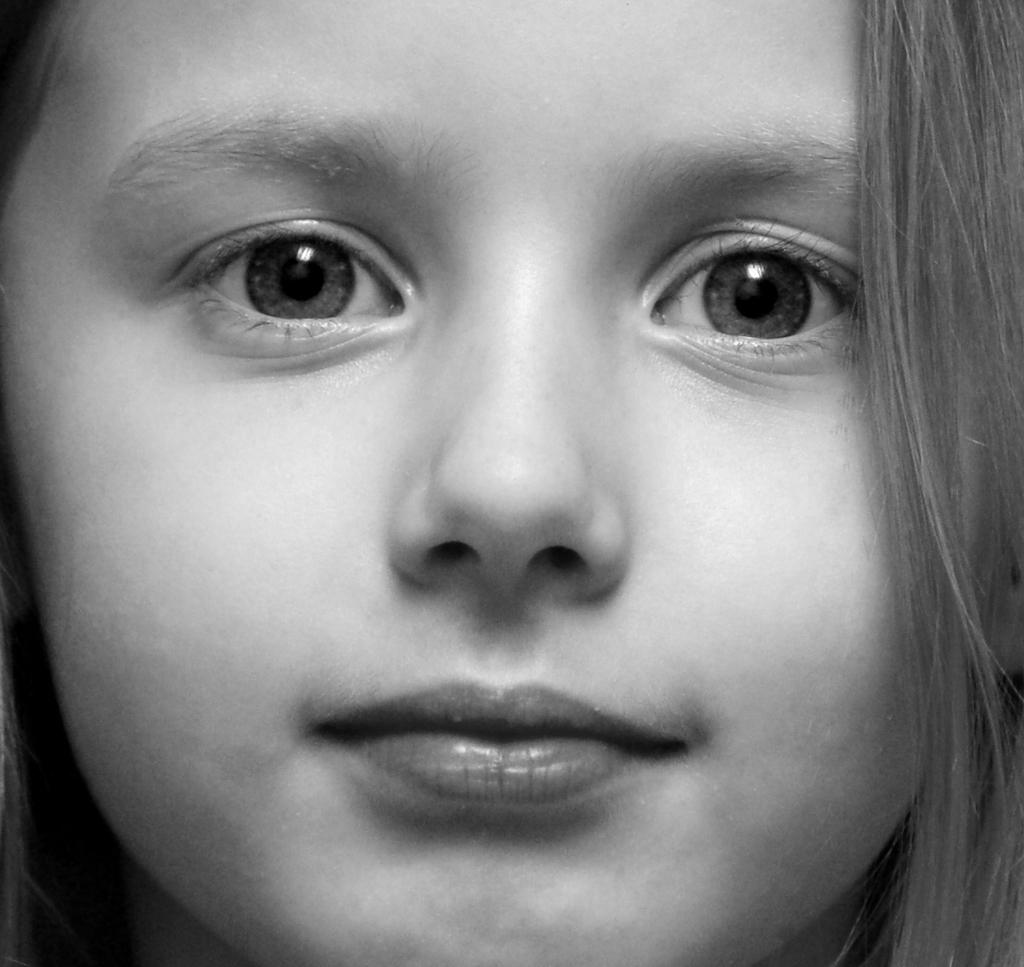What is the color scheme of the image? The image is black and white. Can you describe the main subject of the image? There is a girl in the image. What type of unit can be seen in the image? There is no unit present in the image. How many ears of corn are visible in the image? There are no ears of corn present in the image. 